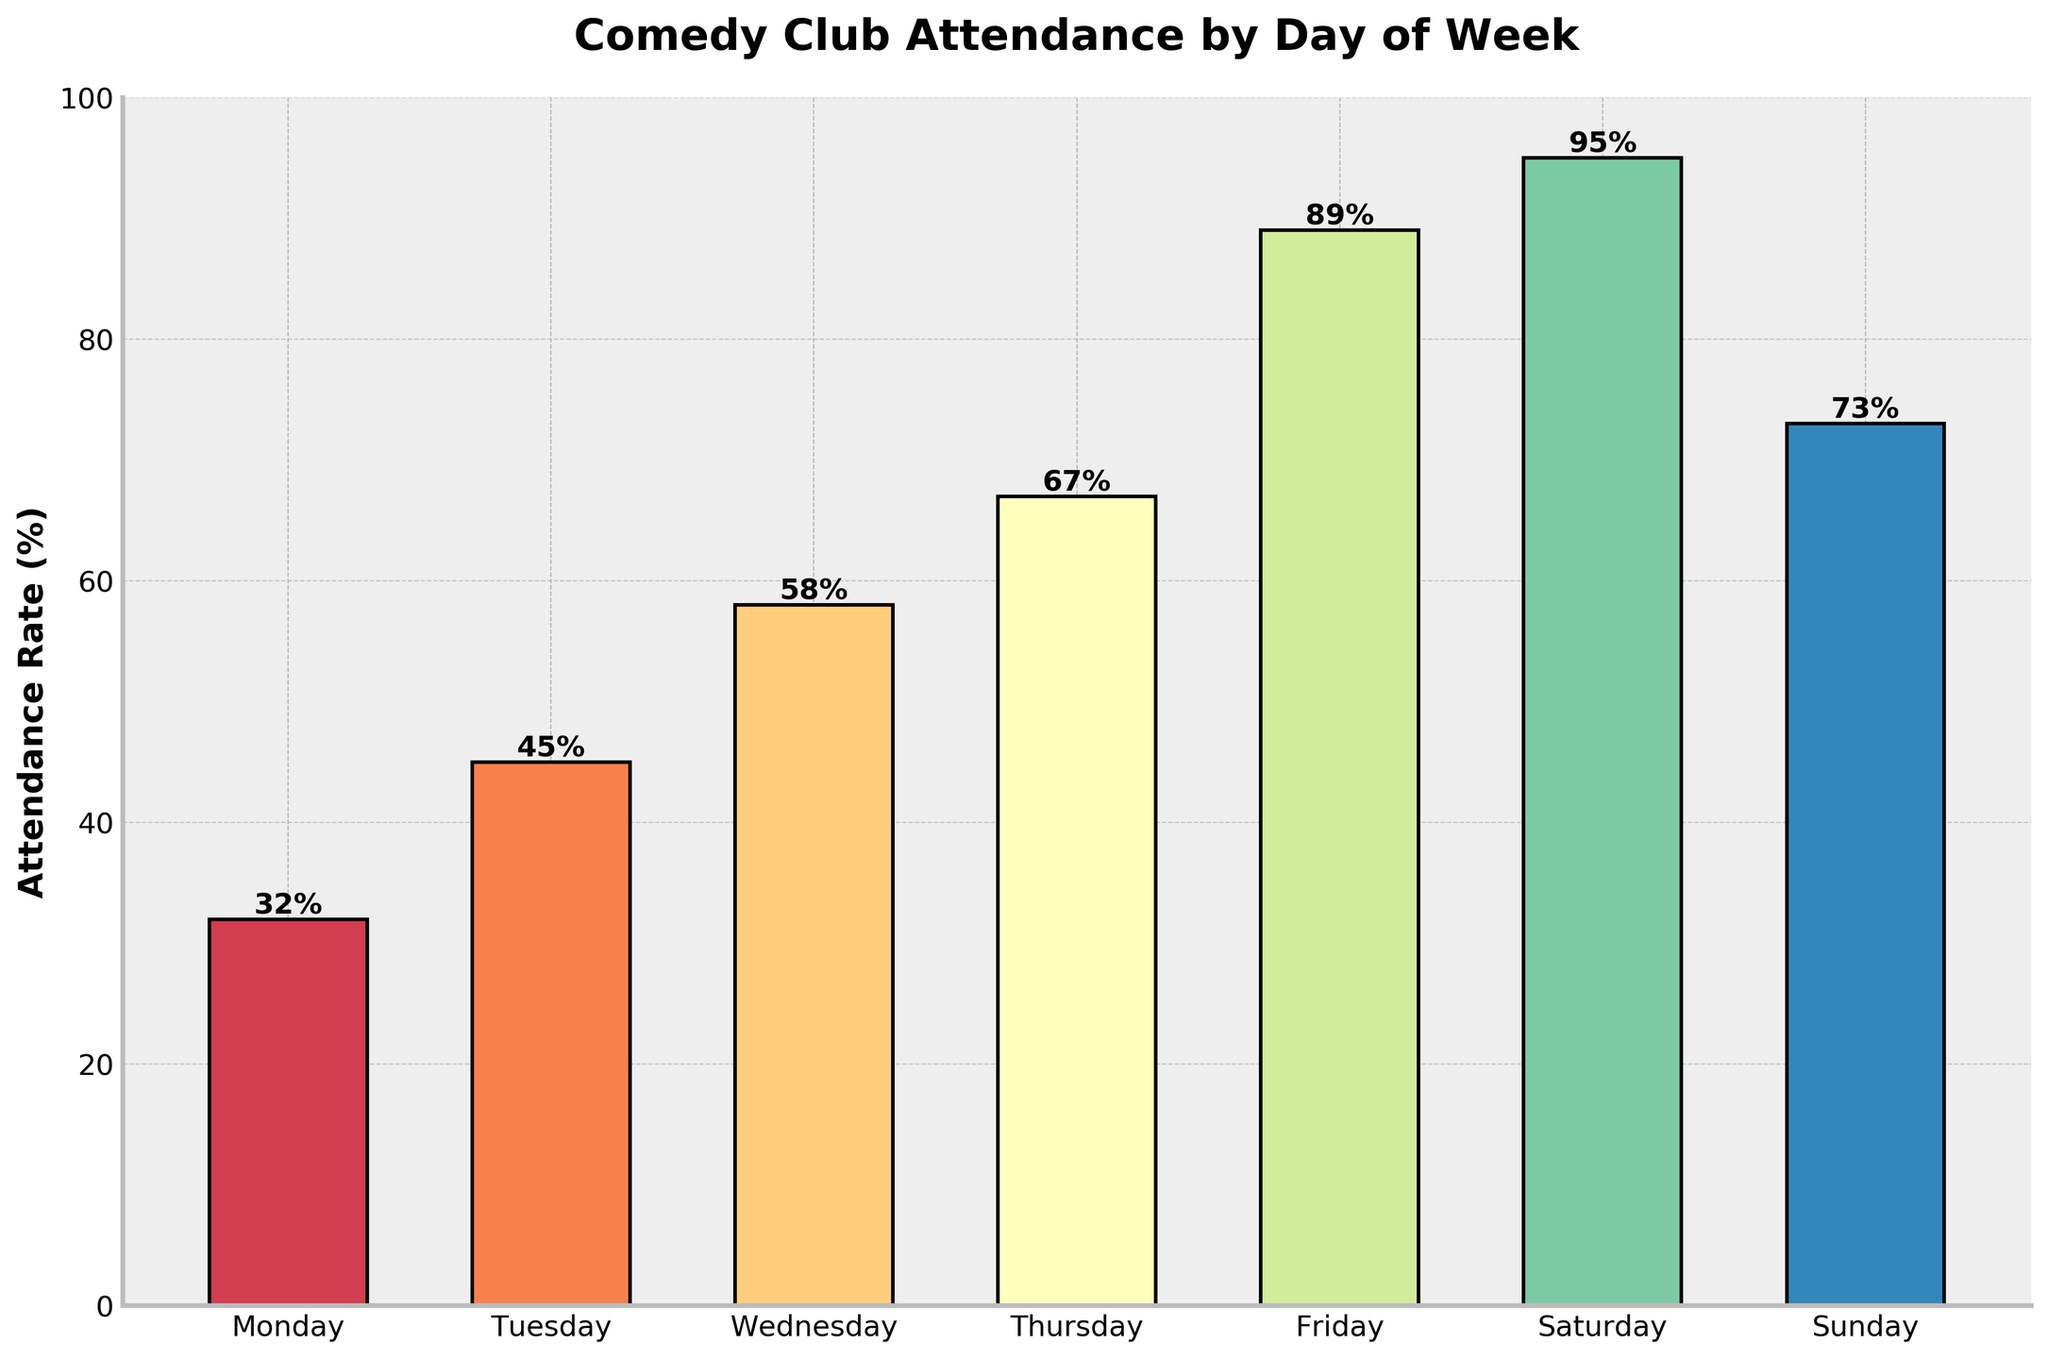What's the day with the highest attendance rate? Look for the bar that reaches the highest point on the chart and check the corresponding day label at the bottom. The tallest bar represents the day with the highest attendance.
Answer: Saturday Which day has the lowest attendance rate? Find the shortest bar in the chart and check the label at the bottom. The shortest bar represents the day with the least attendance.
Answer: Monday Compare the attendance rates of Sunday and Thursday. Which day has a higher rate? Look at the heights of the bars corresponding to Sunday and Thursday. Compare their heights to determine which one is taller. The taller bar indicates the higher attendance rate.
Answer: Thursday What's the average attendance rate across all days? Add the attendance rates for each day: 32% + 45% + 58% + 67% + 89% + 95% + 73%. Divide the sum by the number of days, which is 7. (32 + 45 + 58 + 67 + 89 + 95 + 73)/7 = 65.57
Answer: 65.57% By how much does the attendance on Friday exceed that on Monday? Subtract the attendance rate of Monday from that of Friday. 89% (Friday) - 32% (Monday) = 57%
Answer: 57% What is the total attendance rate for Monday, Tuesday, and Wednesday combined? Add the attendance rates for Monday, Tuesday, and Wednesday. 32% + 45% + 58% = 135%
Answer: 135% Is the attendance rate on Sunday closer to that of Saturday or Friday? Compare the difference between Sunday and Saturday, and Sunday and Friday. Sunday to Saturday: 95% - 73% = 22%. Sunday to Friday: 89% - 73% = 16%. The smaller difference indicates which day is closer.
Answer: Friday On which days does the attendance rate exceed 70%? Check all the bars that go above the 70% mark. Identify and list their respective day labels.
Answer: Thursday, Friday, Saturday, Sunday What is the median attendance rate for the week? Arrange the attendance rates in ascending order and find the middle value. Ordered rates: 32%, 45%, 58%, 67%, 73%, 89%, 95%. The median value is the one in the middle, which is the 4th value in this ordered list.
Answer: 67% How much higher is the Saturday attendance compared to the average attendance of Monday, Tuesday, and Wednesday? First, find the average attendance for Monday, Tuesday, and Wednesday. (32% + 45% + 58%) / 3 = 45%. Then, subtract this average from the Saturday attendance rate. 95% - 45% = 50%
Answer: 50% 